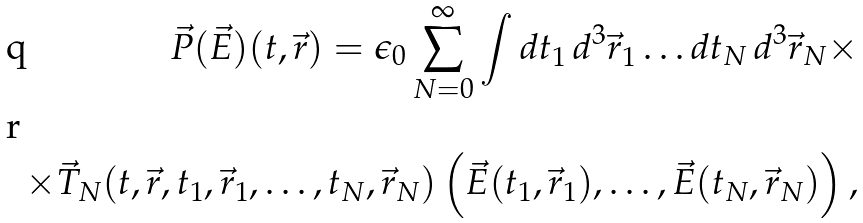<formula> <loc_0><loc_0><loc_500><loc_500>\vec { P } ( \vec { E } ) ( t , \vec { r } ) = \epsilon _ { 0 } \sum _ { N = 0 } ^ { \infty } \int d t _ { 1 } \, d ^ { 3 } \vec { r } _ { 1 } \dots d t _ { N } \, d ^ { 3 } \vec { r } _ { N } \times \\ \times \vec { T } _ { N } ( t , \vec { r } , t _ { 1 } , \vec { r } _ { 1 } , \dots , t _ { N } , \vec { r } _ { N } ) \left ( \vec { E } ( t _ { 1 } , \vec { r } _ { 1 } ) , \dots , \vec { E } ( t _ { N } , \vec { r } _ { N } ) \right ) ,</formula> 